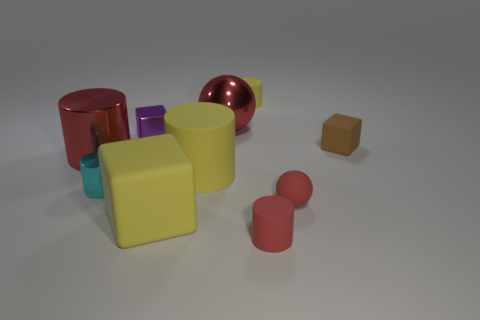There is a shiny object that is the same color as the big sphere; what size is it?
Make the answer very short. Large. There is a cyan cylinder that is made of the same material as the big red ball; what size is it?
Offer a terse response. Small. There is a big red thing that is behind the rubber block to the right of the yellow matte cylinder that is behind the large red shiny cylinder; what shape is it?
Provide a short and direct response. Sphere. The yellow object that is the same shape as the purple thing is what size?
Keep it short and to the point. Large. There is a cube that is left of the small red ball and behind the cyan metal cylinder; what is its size?
Make the answer very short. Small. What is the shape of the matte thing that is the same color as the small matte sphere?
Ensure brevity in your answer.  Cylinder. What is the color of the small shiny cylinder?
Your response must be concise. Cyan. How big is the red cylinder that is to the left of the big yellow matte cube?
Offer a very short reply. Large. What number of matte cubes are behind the block that is in front of the tiny block in front of the purple object?
Keep it short and to the point. 1. What is the color of the sphere behind the red cylinder on the left side of the big sphere?
Your answer should be very brief. Red. 